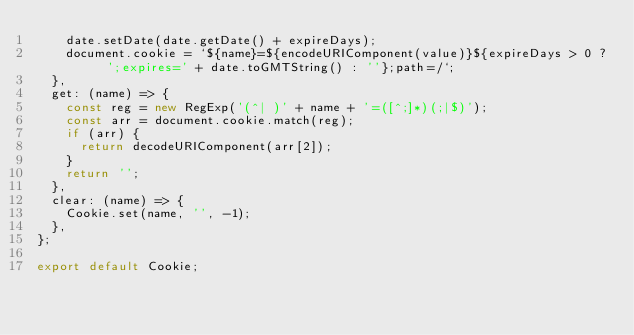Convert code to text. <code><loc_0><loc_0><loc_500><loc_500><_JavaScript_>    date.setDate(date.getDate() + expireDays);
    document.cookie = `${name}=${encodeURIComponent(value)}${expireDays > 0 ? ';expires=' + date.toGMTString() : ''};path=/`;
  },
  get: (name) => {
    const reg = new RegExp('(^| )' + name + '=([^;]*)(;|$)');
    const arr = document.cookie.match(reg);
    if (arr) {
      return decodeURIComponent(arr[2]);
    }
    return '';
  },
  clear: (name) => {
    Cookie.set(name, '', -1);
  },
};

export default Cookie;
</code> 